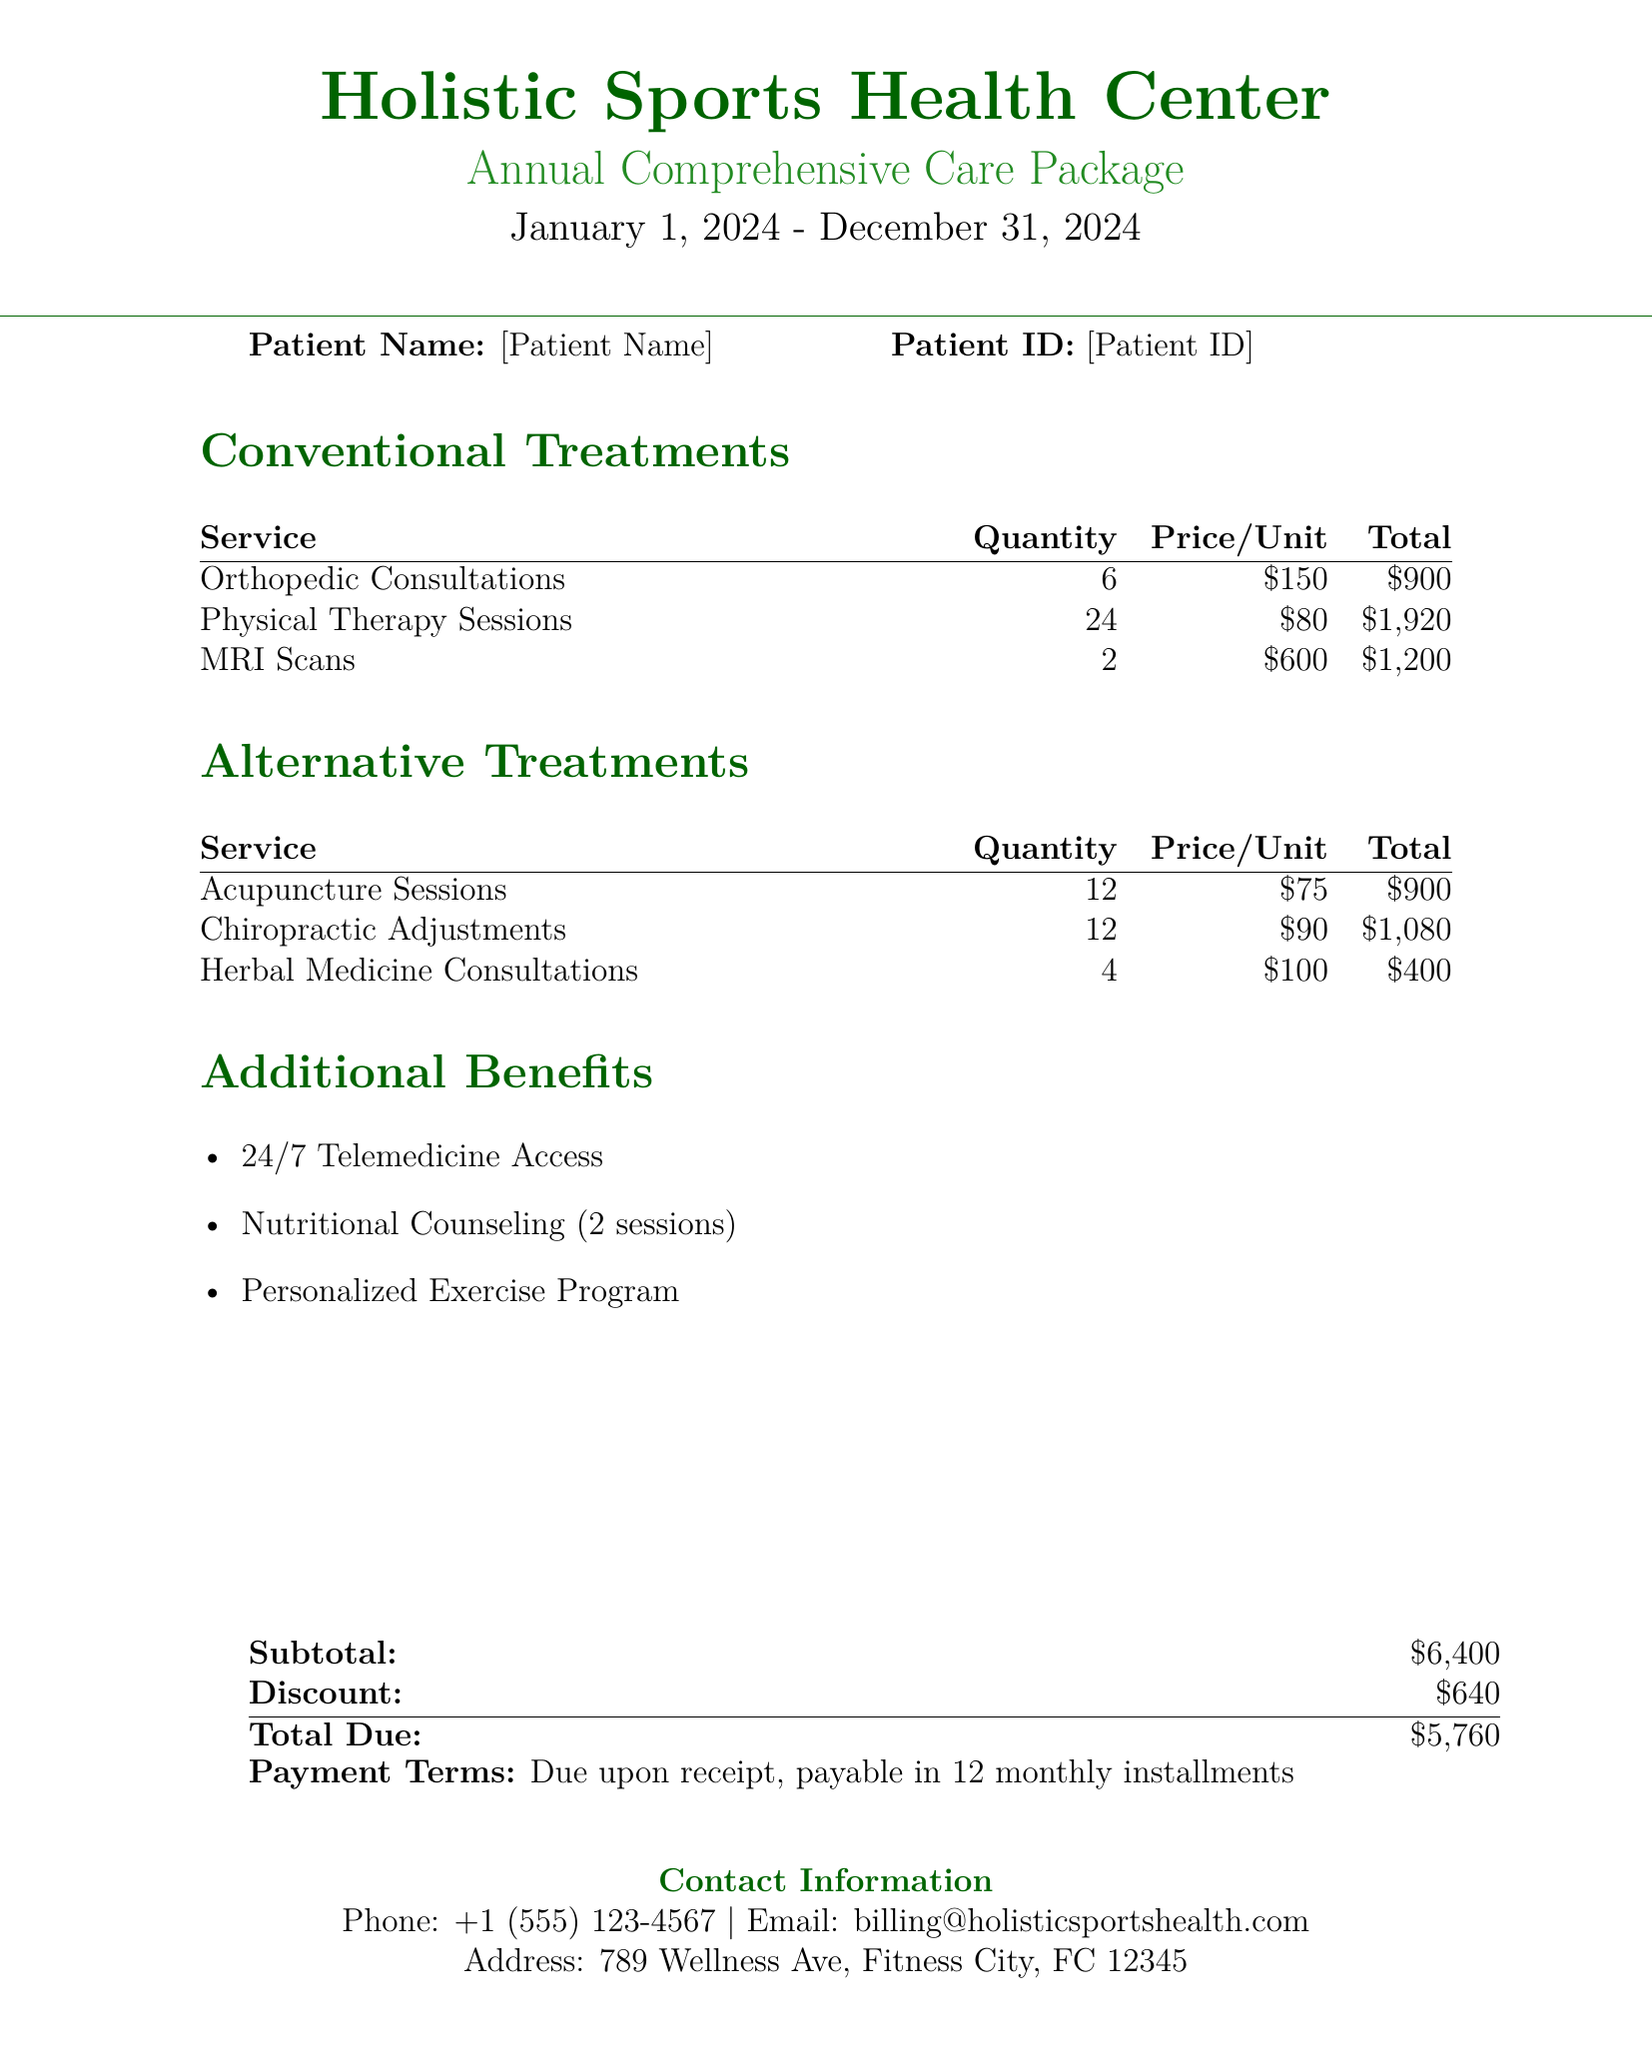What is the total due? The total due is listed at the bottom of the document, calculated after the discount is applied.
Answer: $5,760 How many orthopedic consultations are included? The document specifies the quantity of orthopedic consultations that are part of the conventional treatments.
Answer: 6 What is the quantity of acupuncture sessions? The quantity of acupuncture sessions is stated in the alternative treatments section of the document.
Answer: 12 What is the price per herbal medicine consultation? The price for each herbal medicine consultation is listed in the alternative treatments section.
Answer: $100 What additional benefit is available for telemedicine? The document mentions a specific benefit related to telemedicine access that is available to patients.
Answer: 24/7 Telemedicine Access What is the discount amount? The discount amount is provided in the summary of costs at the bottom of the document.
Answer: $640 How many physical therapy sessions are there? The document specifies the number of physical therapy sessions included in the conventional treatments.
Answer: 24 What is the total cost of the chiropractic adjustments? The total cost for chiropractic adjustments can be calculated by multiplying the quantity and price per unit given in the document.
Answer: $1,080 What payment terms are stated in the document? The document outlines the payment terms regarding when payment is due and how it can be made.
Answer: Due upon receipt, payable in 12 monthly installments 